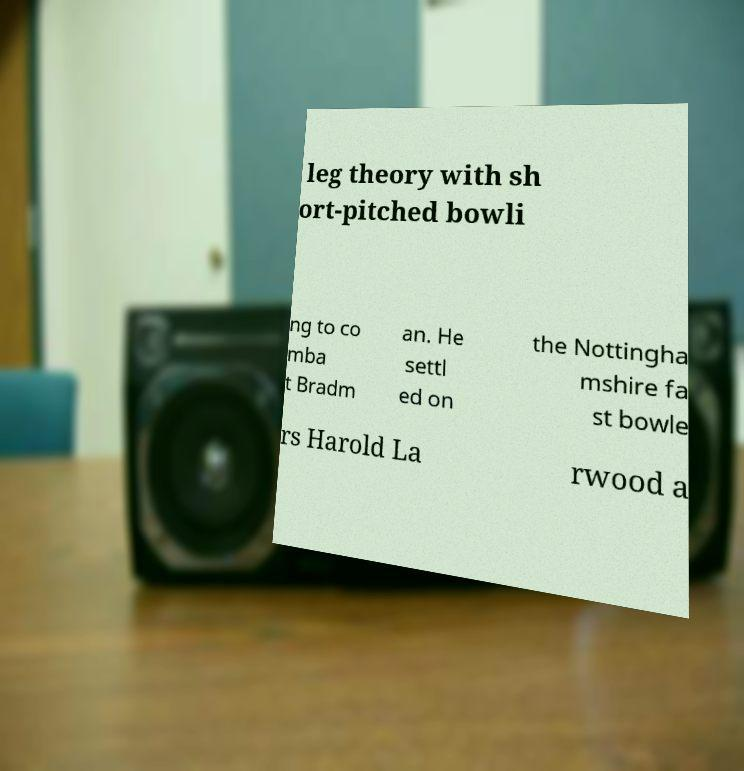Please identify and transcribe the text found in this image. leg theory with sh ort-pitched bowli ng to co mba t Bradm an. He settl ed on the Nottingha mshire fa st bowle rs Harold La rwood a 